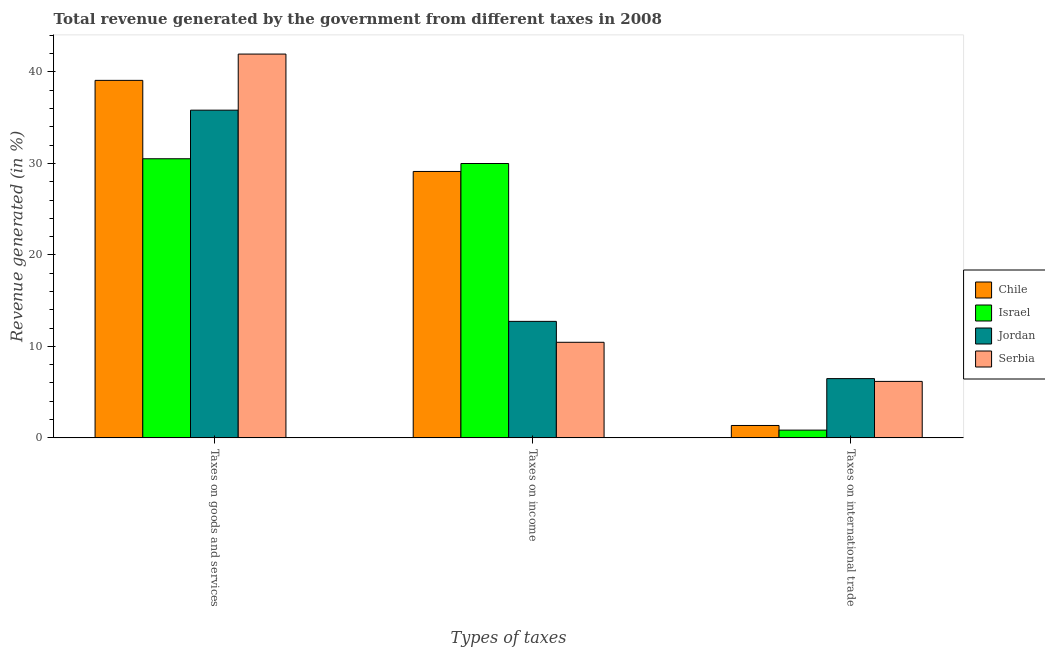How many different coloured bars are there?
Ensure brevity in your answer.  4. How many groups of bars are there?
Your answer should be compact. 3. How many bars are there on the 3rd tick from the left?
Offer a terse response. 4. What is the label of the 2nd group of bars from the left?
Keep it short and to the point. Taxes on income. What is the percentage of revenue generated by tax on international trade in Serbia?
Keep it short and to the point. 6.17. Across all countries, what is the maximum percentage of revenue generated by tax on international trade?
Provide a succinct answer. 6.48. Across all countries, what is the minimum percentage of revenue generated by taxes on income?
Keep it short and to the point. 10.45. In which country was the percentage of revenue generated by tax on international trade maximum?
Your answer should be very brief. Jordan. In which country was the percentage of revenue generated by taxes on income minimum?
Offer a very short reply. Serbia. What is the total percentage of revenue generated by tax on international trade in the graph?
Your answer should be compact. 14.85. What is the difference between the percentage of revenue generated by taxes on income in Chile and that in Jordan?
Ensure brevity in your answer.  16.39. What is the difference between the percentage of revenue generated by taxes on income in Serbia and the percentage of revenue generated by tax on international trade in Israel?
Provide a succinct answer. 9.6. What is the average percentage of revenue generated by tax on international trade per country?
Ensure brevity in your answer.  3.71. What is the difference between the percentage of revenue generated by taxes on income and percentage of revenue generated by tax on international trade in Israel?
Offer a very short reply. 29.14. What is the ratio of the percentage of revenue generated by tax on international trade in Chile to that in Jordan?
Provide a short and direct response. 0.21. What is the difference between the highest and the second highest percentage of revenue generated by taxes on goods and services?
Make the answer very short. 2.88. What is the difference between the highest and the lowest percentage of revenue generated by taxes on goods and services?
Offer a very short reply. 11.44. In how many countries, is the percentage of revenue generated by taxes on goods and services greater than the average percentage of revenue generated by taxes on goods and services taken over all countries?
Offer a very short reply. 2. Is it the case that in every country, the sum of the percentage of revenue generated by taxes on goods and services and percentage of revenue generated by taxes on income is greater than the percentage of revenue generated by tax on international trade?
Your response must be concise. Yes. How many bars are there?
Your response must be concise. 12. How many countries are there in the graph?
Your answer should be very brief. 4. Are the values on the major ticks of Y-axis written in scientific E-notation?
Ensure brevity in your answer.  No. Does the graph contain grids?
Provide a short and direct response. No. Where does the legend appear in the graph?
Ensure brevity in your answer.  Center right. What is the title of the graph?
Provide a short and direct response. Total revenue generated by the government from different taxes in 2008. What is the label or title of the X-axis?
Your response must be concise. Types of taxes. What is the label or title of the Y-axis?
Your answer should be compact. Revenue generated (in %). What is the Revenue generated (in %) of Chile in Taxes on goods and services?
Keep it short and to the point. 39.08. What is the Revenue generated (in %) of Israel in Taxes on goods and services?
Give a very brief answer. 30.51. What is the Revenue generated (in %) in Jordan in Taxes on goods and services?
Give a very brief answer. 35.82. What is the Revenue generated (in %) in Serbia in Taxes on goods and services?
Your answer should be very brief. 41.95. What is the Revenue generated (in %) in Chile in Taxes on income?
Ensure brevity in your answer.  29.12. What is the Revenue generated (in %) of Israel in Taxes on income?
Provide a short and direct response. 29.99. What is the Revenue generated (in %) in Jordan in Taxes on income?
Provide a succinct answer. 12.73. What is the Revenue generated (in %) of Serbia in Taxes on income?
Your response must be concise. 10.45. What is the Revenue generated (in %) of Chile in Taxes on international trade?
Keep it short and to the point. 1.35. What is the Revenue generated (in %) in Israel in Taxes on international trade?
Ensure brevity in your answer.  0.85. What is the Revenue generated (in %) in Jordan in Taxes on international trade?
Keep it short and to the point. 6.48. What is the Revenue generated (in %) of Serbia in Taxes on international trade?
Your response must be concise. 6.17. Across all Types of taxes, what is the maximum Revenue generated (in %) in Chile?
Offer a terse response. 39.08. Across all Types of taxes, what is the maximum Revenue generated (in %) of Israel?
Offer a terse response. 30.51. Across all Types of taxes, what is the maximum Revenue generated (in %) in Jordan?
Your answer should be compact. 35.82. Across all Types of taxes, what is the maximum Revenue generated (in %) of Serbia?
Give a very brief answer. 41.95. Across all Types of taxes, what is the minimum Revenue generated (in %) in Chile?
Ensure brevity in your answer.  1.35. Across all Types of taxes, what is the minimum Revenue generated (in %) of Israel?
Provide a short and direct response. 0.85. Across all Types of taxes, what is the minimum Revenue generated (in %) of Jordan?
Make the answer very short. 6.48. Across all Types of taxes, what is the minimum Revenue generated (in %) of Serbia?
Your response must be concise. 6.17. What is the total Revenue generated (in %) of Chile in the graph?
Ensure brevity in your answer.  69.55. What is the total Revenue generated (in %) of Israel in the graph?
Offer a terse response. 61.35. What is the total Revenue generated (in %) in Jordan in the graph?
Your answer should be compact. 55.03. What is the total Revenue generated (in %) of Serbia in the graph?
Provide a short and direct response. 58.58. What is the difference between the Revenue generated (in %) of Chile in Taxes on goods and services and that in Taxes on income?
Provide a short and direct response. 9.96. What is the difference between the Revenue generated (in %) in Israel in Taxes on goods and services and that in Taxes on income?
Keep it short and to the point. 0.52. What is the difference between the Revenue generated (in %) in Jordan in Taxes on goods and services and that in Taxes on income?
Offer a very short reply. 23.09. What is the difference between the Revenue generated (in %) in Serbia in Taxes on goods and services and that in Taxes on income?
Offer a terse response. 31.51. What is the difference between the Revenue generated (in %) of Chile in Taxes on goods and services and that in Taxes on international trade?
Your answer should be very brief. 37.72. What is the difference between the Revenue generated (in %) of Israel in Taxes on goods and services and that in Taxes on international trade?
Make the answer very short. 29.66. What is the difference between the Revenue generated (in %) of Jordan in Taxes on goods and services and that in Taxes on international trade?
Ensure brevity in your answer.  29.35. What is the difference between the Revenue generated (in %) in Serbia in Taxes on goods and services and that in Taxes on international trade?
Offer a terse response. 35.78. What is the difference between the Revenue generated (in %) of Chile in Taxes on income and that in Taxes on international trade?
Make the answer very short. 27.77. What is the difference between the Revenue generated (in %) of Israel in Taxes on income and that in Taxes on international trade?
Offer a very short reply. 29.14. What is the difference between the Revenue generated (in %) in Jordan in Taxes on income and that in Taxes on international trade?
Your answer should be compact. 6.26. What is the difference between the Revenue generated (in %) of Serbia in Taxes on income and that in Taxes on international trade?
Offer a very short reply. 4.28. What is the difference between the Revenue generated (in %) of Chile in Taxes on goods and services and the Revenue generated (in %) of Israel in Taxes on income?
Give a very brief answer. 9.09. What is the difference between the Revenue generated (in %) of Chile in Taxes on goods and services and the Revenue generated (in %) of Jordan in Taxes on income?
Offer a terse response. 26.34. What is the difference between the Revenue generated (in %) of Chile in Taxes on goods and services and the Revenue generated (in %) of Serbia in Taxes on income?
Your response must be concise. 28.63. What is the difference between the Revenue generated (in %) in Israel in Taxes on goods and services and the Revenue generated (in %) in Jordan in Taxes on income?
Your answer should be compact. 17.77. What is the difference between the Revenue generated (in %) of Israel in Taxes on goods and services and the Revenue generated (in %) of Serbia in Taxes on income?
Offer a terse response. 20.06. What is the difference between the Revenue generated (in %) of Jordan in Taxes on goods and services and the Revenue generated (in %) of Serbia in Taxes on income?
Ensure brevity in your answer.  25.37. What is the difference between the Revenue generated (in %) in Chile in Taxes on goods and services and the Revenue generated (in %) in Israel in Taxes on international trade?
Your answer should be very brief. 38.23. What is the difference between the Revenue generated (in %) of Chile in Taxes on goods and services and the Revenue generated (in %) of Jordan in Taxes on international trade?
Keep it short and to the point. 32.6. What is the difference between the Revenue generated (in %) of Chile in Taxes on goods and services and the Revenue generated (in %) of Serbia in Taxes on international trade?
Your response must be concise. 32.91. What is the difference between the Revenue generated (in %) in Israel in Taxes on goods and services and the Revenue generated (in %) in Jordan in Taxes on international trade?
Offer a very short reply. 24.03. What is the difference between the Revenue generated (in %) of Israel in Taxes on goods and services and the Revenue generated (in %) of Serbia in Taxes on international trade?
Your response must be concise. 24.34. What is the difference between the Revenue generated (in %) of Jordan in Taxes on goods and services and the Revenue generated (in %) of Serbia in Taxes on international trade?
Offer a very short reply. 29.65. What is the difference between the Revenue generated (in %) of Chile in Taxes on income and the Revenue generated (in %) of Israel in Taxes on international trade?
Make the answer very short. 28.27. What is the difference between the Revenue generated (in %) of Chile in Taxes on income and the Revenue generated (in %) of Jordan in Taxes on international trade?
Your answer should be compact. 22.65. What is the difference between the Revenue generated (in %) of Chile in Taxes on income and the Revenue generated (in %) of Serbia in Taxes on international trade?
Keep it short and to the point. 22.95. What is the difference between the Revenue generated (in %) of Israel in Taxes on income and the Revenue generated (in %) of Jordan in Taxes on international trade?
Make the answer very short. 23.51. What is the difference between the Revenue generated (in %) of Israel in Taxes on income and the Revenue generated (in %) of Serbia in Taxes on international trade?
Keep it short and to the point. 23.82. What is the difference between the Revenue generated (in %) of Jordan in Taxes on income and the Revenue generated (in %) of Serbia in Taxes on international trade?
Make the answer very short. 6.56. What is the average Revenue generated (in %) of Chile per Types of taxes?
Offer a very short reply. 23.18. What is the average Revenue generated (in %) in Israel per Types of taxes?
Provide a short and direct response. 20.45. What is the average Revenue generated (in %) of Jordan per Types of taxes?
Provide a short and direct response. 18.34. What is the average Revenue generated (in %) in Serbia per Types of taxes?
Provide a succinct answer. 19.53. What is the difference between the Revenue generated (in %) in Chile and Revenue generated (in %) in Israel in Taxes on goods and services?
Provide a short and direct response. 8.57. What is the difference between the Revenue generated (in %) of Chile and Revenue generated (in %) of Jordan in Taxes on goods and services?
Make the answer very short. 3.26. What is the difference between the Revenue generated (in %) of Chile and Revenue generated (in %) of Serbia in Taxes on goods and services?
Offer a very short reply. -2.88. What is the difference between the Revenue generated (in %) of Israel and Revenue generated (in %) of Jordan in Taxes on goods and services?
Your answer should be very brief. -5.31. What is the difference between the Revenue generated (in %) of Israel and Revenue generated (in %) of Serbia in Taxes on goods and services?
Your answer should be compact. -11.44. What is the difference between the Revenue generated (in %) in Jordan and Revenue generated (in %) in Serbia in Taxes on goods and services?
Your response must be concise. -6.13. What is the difference between the Revenue generated (in %) in Chile and Revenue generated (in %) in Israel in Taxes on income?
Provide a short and direct response. -0.87. What is the difference between the Revenue generated (in %) in Chile and Revenue generated (in %) in Jordan in Taxes on income?
Your response must be concise. 16.39. What is the difference between the Revenue generated (in %) in Chile and Revenue generated (in %) in Serbia in Taxes on income?
Make the answer very short. 18.67. What is the difference between the Revenue generated (in %) in Israel and Revenue generated (in %) in Jordan in Taxes on income?
Your answer should be very brief. 17.26. What is the difference between the Revenue generated (in %) in Israel and Revenue generated (in %) in Serbia in Taxes on income?
Provide a short and direct response. 19.54. What is the difference between the Revenue generated (in %) in Jordan and Revenue generated (in %) in Serbia in Taxes on income?
Offer a very short reply. 2.29. What is the difference between the Revenue generated (in %) in Chile and Revenue generated (in %) in Israel in Taxes on international trade?
Ensure brevity in your answer.  0.51. What is the difference between the Revenue generated (in %) of Chile and Revenue generated (in %) of Jordan in Taxes on international trade?
Make the answer very short. -5.12. What is the difference between the Revenue generated (in %) of Chile and Revenue generated (in %) of Serbia in Taxes on international trade?
Give a very brief answer. -4.82. What is the difference between the Revenue generated (in %) in Israel and Revenue generated (in %) in Jordan in Taxes on international trade?
Give a very brief answer. -5.63. What is the difference between the Revenue generated (in %) of Israel and Revenue generated (in %) of Serbia in Taxes on international trade?
Make the answer very short. -5.32. What is the difference between the Revenue generated (in %) of Jordan and Revenue generated (in %) of Serbia in Taxes on international trade?
Your response must be concise. 0.3. What is the ratio of the Revenue generated (in %) of Chile in Taxes on goods and services to that in Taxes on income?
Provide a succinct answer. 1.34. What is the ratio of the Revenue generated (in %) in Israel in Taxes on goods and services to that in Taxes on income?
Your answer should be compact. 1.02. What is the ratio of the Revenue generated (in %) in Jordan in Taxes on goods and services to that in Taxes on income?
Your response must be concise. 2.81. What is the ratio of the Revenue generated (in %) of Serbia in Taxes on goods and services to that in Taxes on income?
Keep it short and to the point. 4.02. What is the ratio of the Revenue generated (in %) in Chile in Taxes on goods and services to that in Taxes on international trade?
Your response must be concise. 28.85. What is the ratio of the Revenue generated (in %) in Israel in Taxes on goods and services to that in Taxes on international trade?
Your response must be concise. 35.99. What is the ratio of the Revenue generated (in %) of Jordan in Taxes on goods and services to that in Taxes on international trade?
Keep it short and to the point. 5.53. What is the ratio of the Revenue generated (in %) in Serbia in Taxes on goods and services to that in Taxes on international trade?
Provide a succinct answer. 6.8. What is the ratio of the Revenue generated (in %) in Chile in Taxes on income to that in Taxes on international trade?
Your response must be concise. 21.5. What is the ratio of the Revenue generated (in %) in Israel in Taxes on income to that in Taxes on international trade?
Your answer should be very brief. 35.38. What is the ratio of the Revenue generated (in %) of Jordan in Taxes on income to that in Taxes on international trade?
Keep it short and to the point. 1.97. What is the ratio of the Revenue generated (in %) of Serbia in Taxes on income to that in Taxes on international trade?
Make the answer very short. 1.69. What is the difference between the highest and the second highest Revenue generated (in %) in Chile?
Give a very brief answer. 9.96. What is the difference between the highest and the second highest Revenue generated (in %) in Israel?
Make the answer very short. 0.52. What is the difference between the highest and the second highest Revenue generated (in %) of Jordan?
Give a very brief answer. 23.09. What is the difference between the highest and the second highest Revenue generated (in %) in Serbia?
Provide a succinct answer. 31.51. What is the difference between the highest and the lowest Revenue generated (in %) of Chile?
Your response must be concise. 37.72. What is the difference between the highest and the lowest Revenue generated (in %) of Israel?
Your answer should be compact. 29.66. What is the difference between the highest and the lowest Revenue generated (in %) in Jordan?
Your answer should be very brief. 29.35. What is the difference between the highest and the lowest Revenue generated (in %) in Serbia?
Offer a terse response. 35.78. 